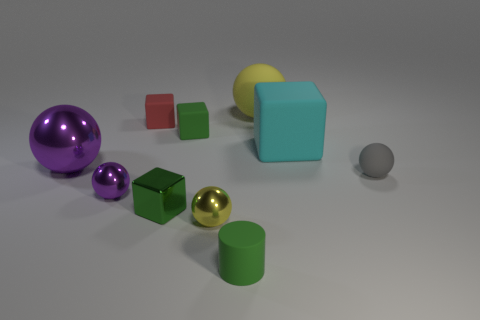Subtract 1 balls. How many balls are left? 4 Subtract all gray spheres. How many spheres are left? 4 Subtract all yellow rubber balls. How many balls are left? 4 Subtract all red spheres. Subtract all green cubes. How many spheres are left? 5 Subtract all cubes. How many objects are left? 6 Subtract all large purple balls. Subtract all tiny yellow metal objects. How many objects are left? 8 Add 6 small rubber cylinders. How many small rubber cylinders are left? 7 Add 8 small cyan metal balls. How many small cyan metal balls exist? 8 Subtract 0 green balls. How many objects are left? 10 